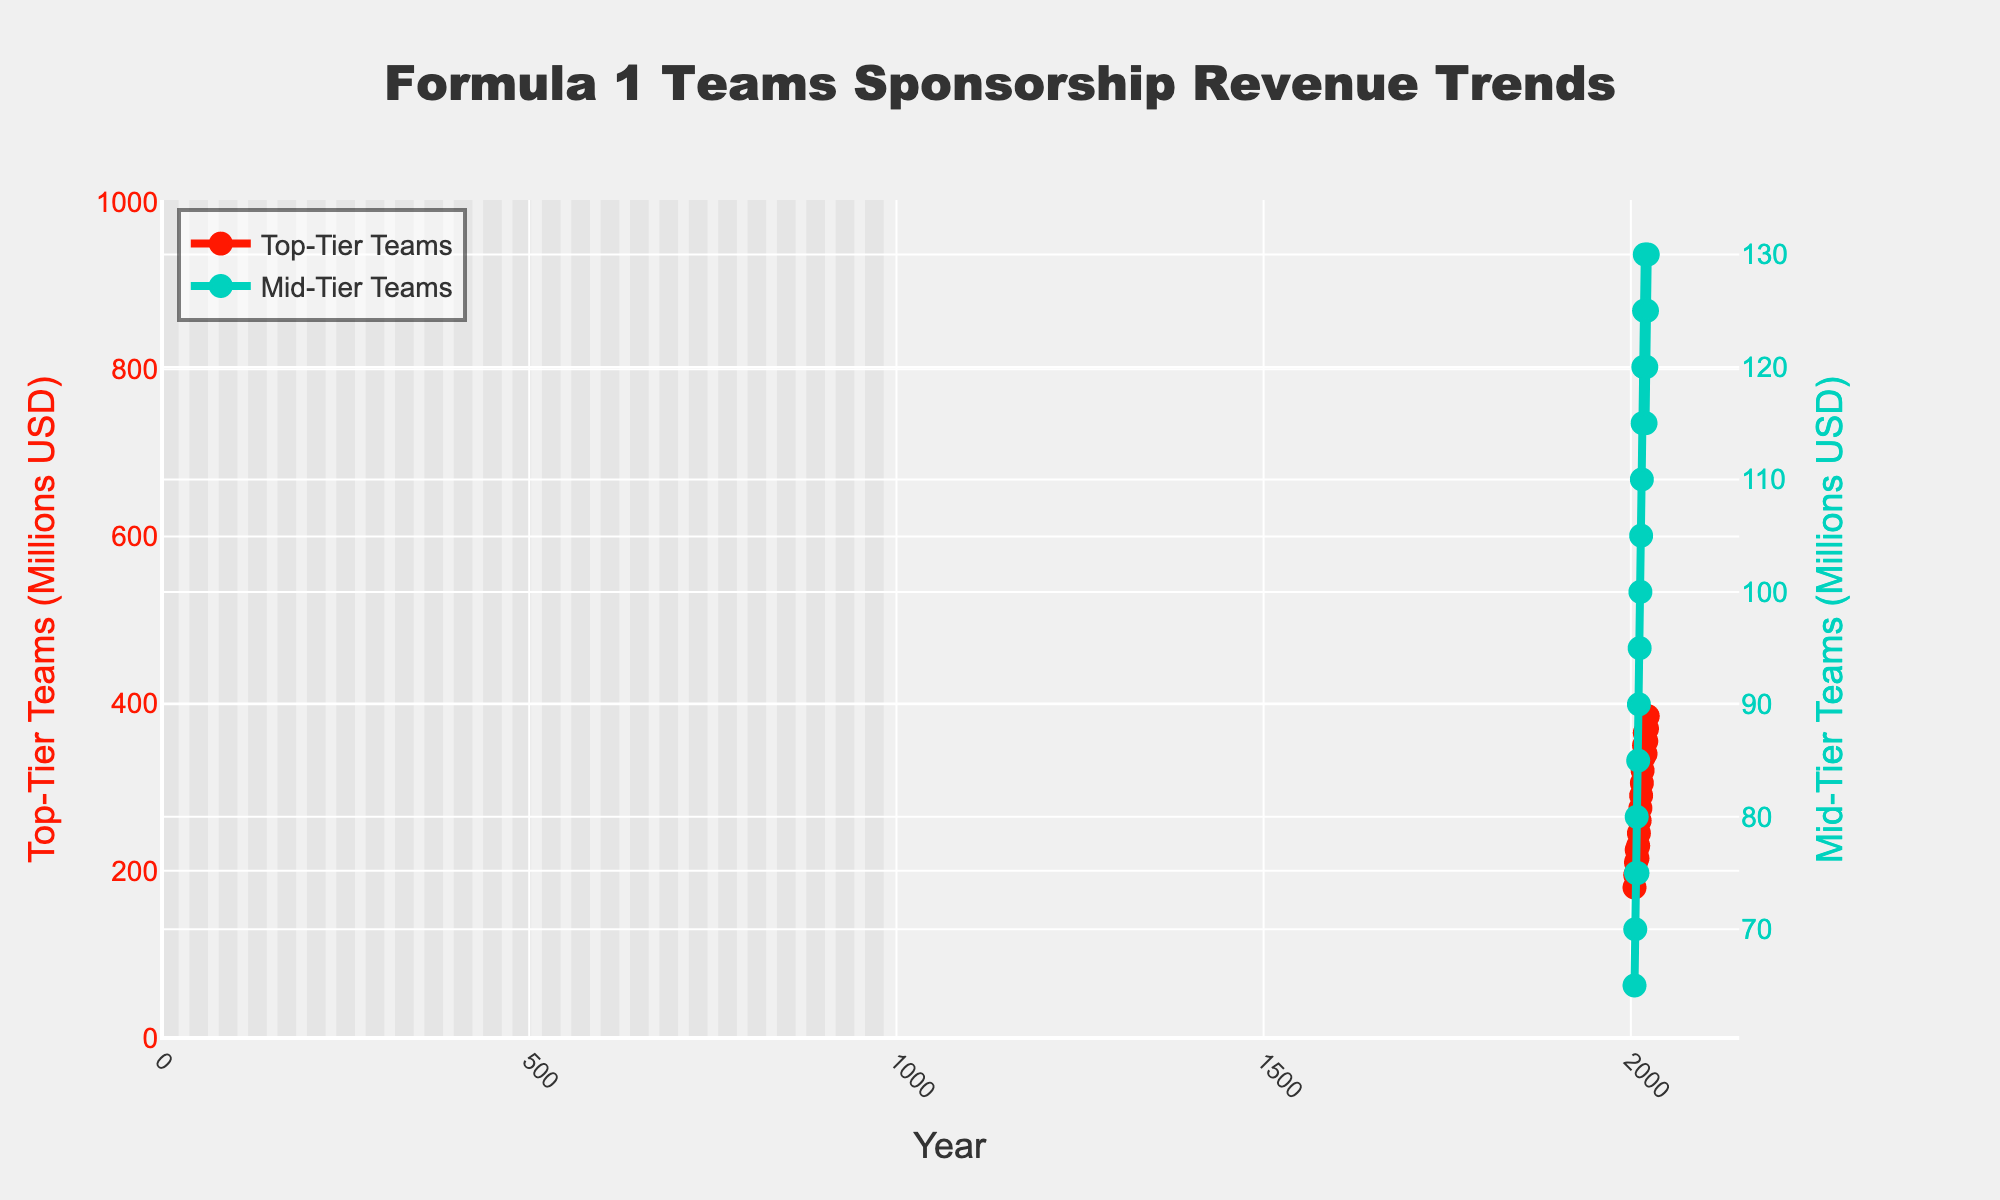what's the sponsorship revenue for top-tier teams in 2010? From the line chart, locate the value for top-tier teams at the year 2010, which is indicated along the vertical axis.
Answer: 230 which year did mid-tier teams first reach 100 million USD in sponsorship revenue? Check the revenue values for mid-tier teams year by year until the first instance that equals or exceeds 100 million USD. This occurs in 2013.
Answer: 2013 how much did the sponsorship revenue for top-tier teams decrease from 2019 to 2020? Note the values for top-tier teams in 2019 (365 million USD) and 2020 (340 million USD). Subtract the 2020 value from the 2019 value: 365 - 340.
Answer: 25 what is the difference in sponsorship revenues between top-tier and mid-tier teams in 2023? From the 2023 values, top-tier teams have 385 million USD and mid-tier teams have 130 million USD. Subtract the mid-tier value from the top-tier value: 385 - 130.
Answer: 255 in which year did both top-tier and mid-tier teams have the same pattern of increasing sponsorship revenue? Observe both lines to identify years where both lines trend upwards. This occurs consistently in multiple consecutive periods, for example from 2005-2008, 2010-2019.
Answer: 2005-2008, 2010-2019 what's the average sponsorship revenue for mid-tier teams between 2017-2023? Find the values for mid-tier teams from 2017 (120 million USD) to 2023 (130 million USD), add them together (120+125+130+115+120+125+130=865), and then divide by the number of years (7): 865/7.
Answer: 123.57 by how much did the top-tier teams' sponsorship revenue increase from 2005 to 2023? Identify the 2005 value (180 million USD) and the 2023 value (385 million USD) for top-tier teams. Subtract the 2005 value from the 2023 value: 385 - 180.
Answer: 205 in which year did mid-tier teams experience their largest single-year drop in sponsorship revenue? Identify the values for mid-tier teams each year. Locate the year with the largest negative difference, occurring from 2019 (130 million USD) to 2020 (115 million USD), which is a drop of 15 million USD.
Answer: 2020 